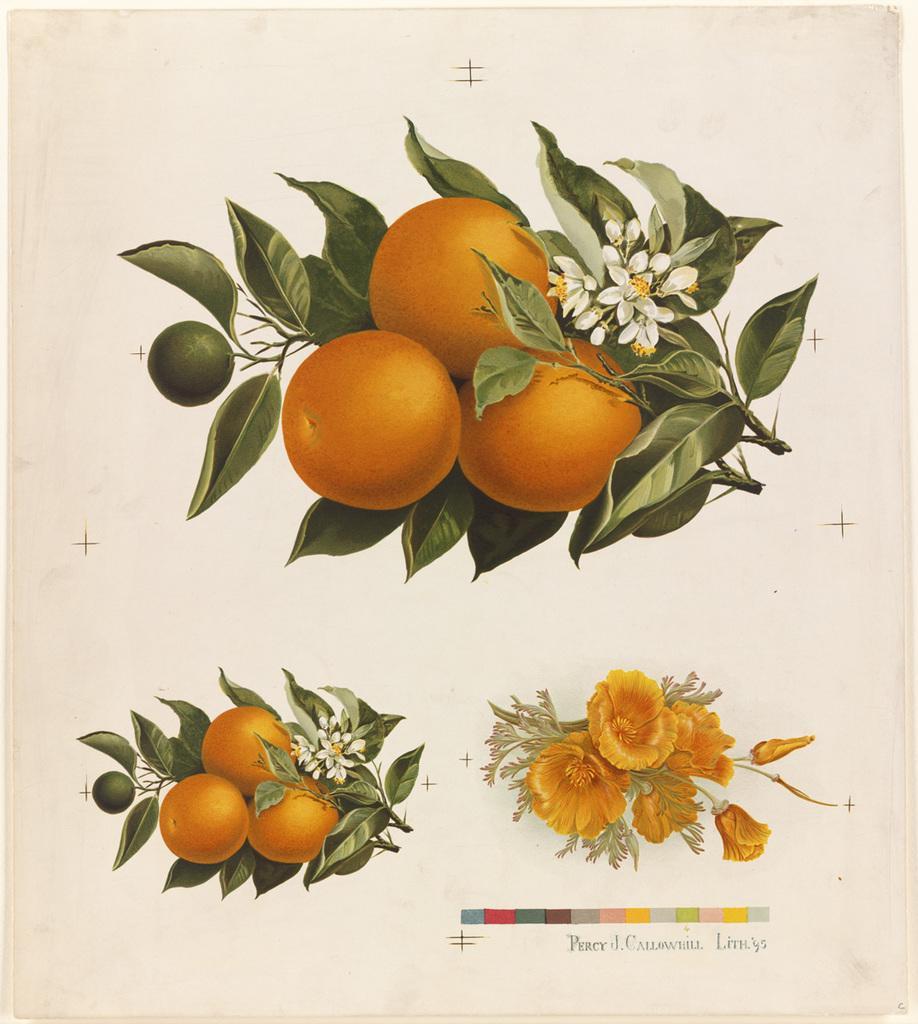In one or two sentences, can you explain what this image depicts? This image consists of a paper on which there is a image of fruits along with green leaves. 